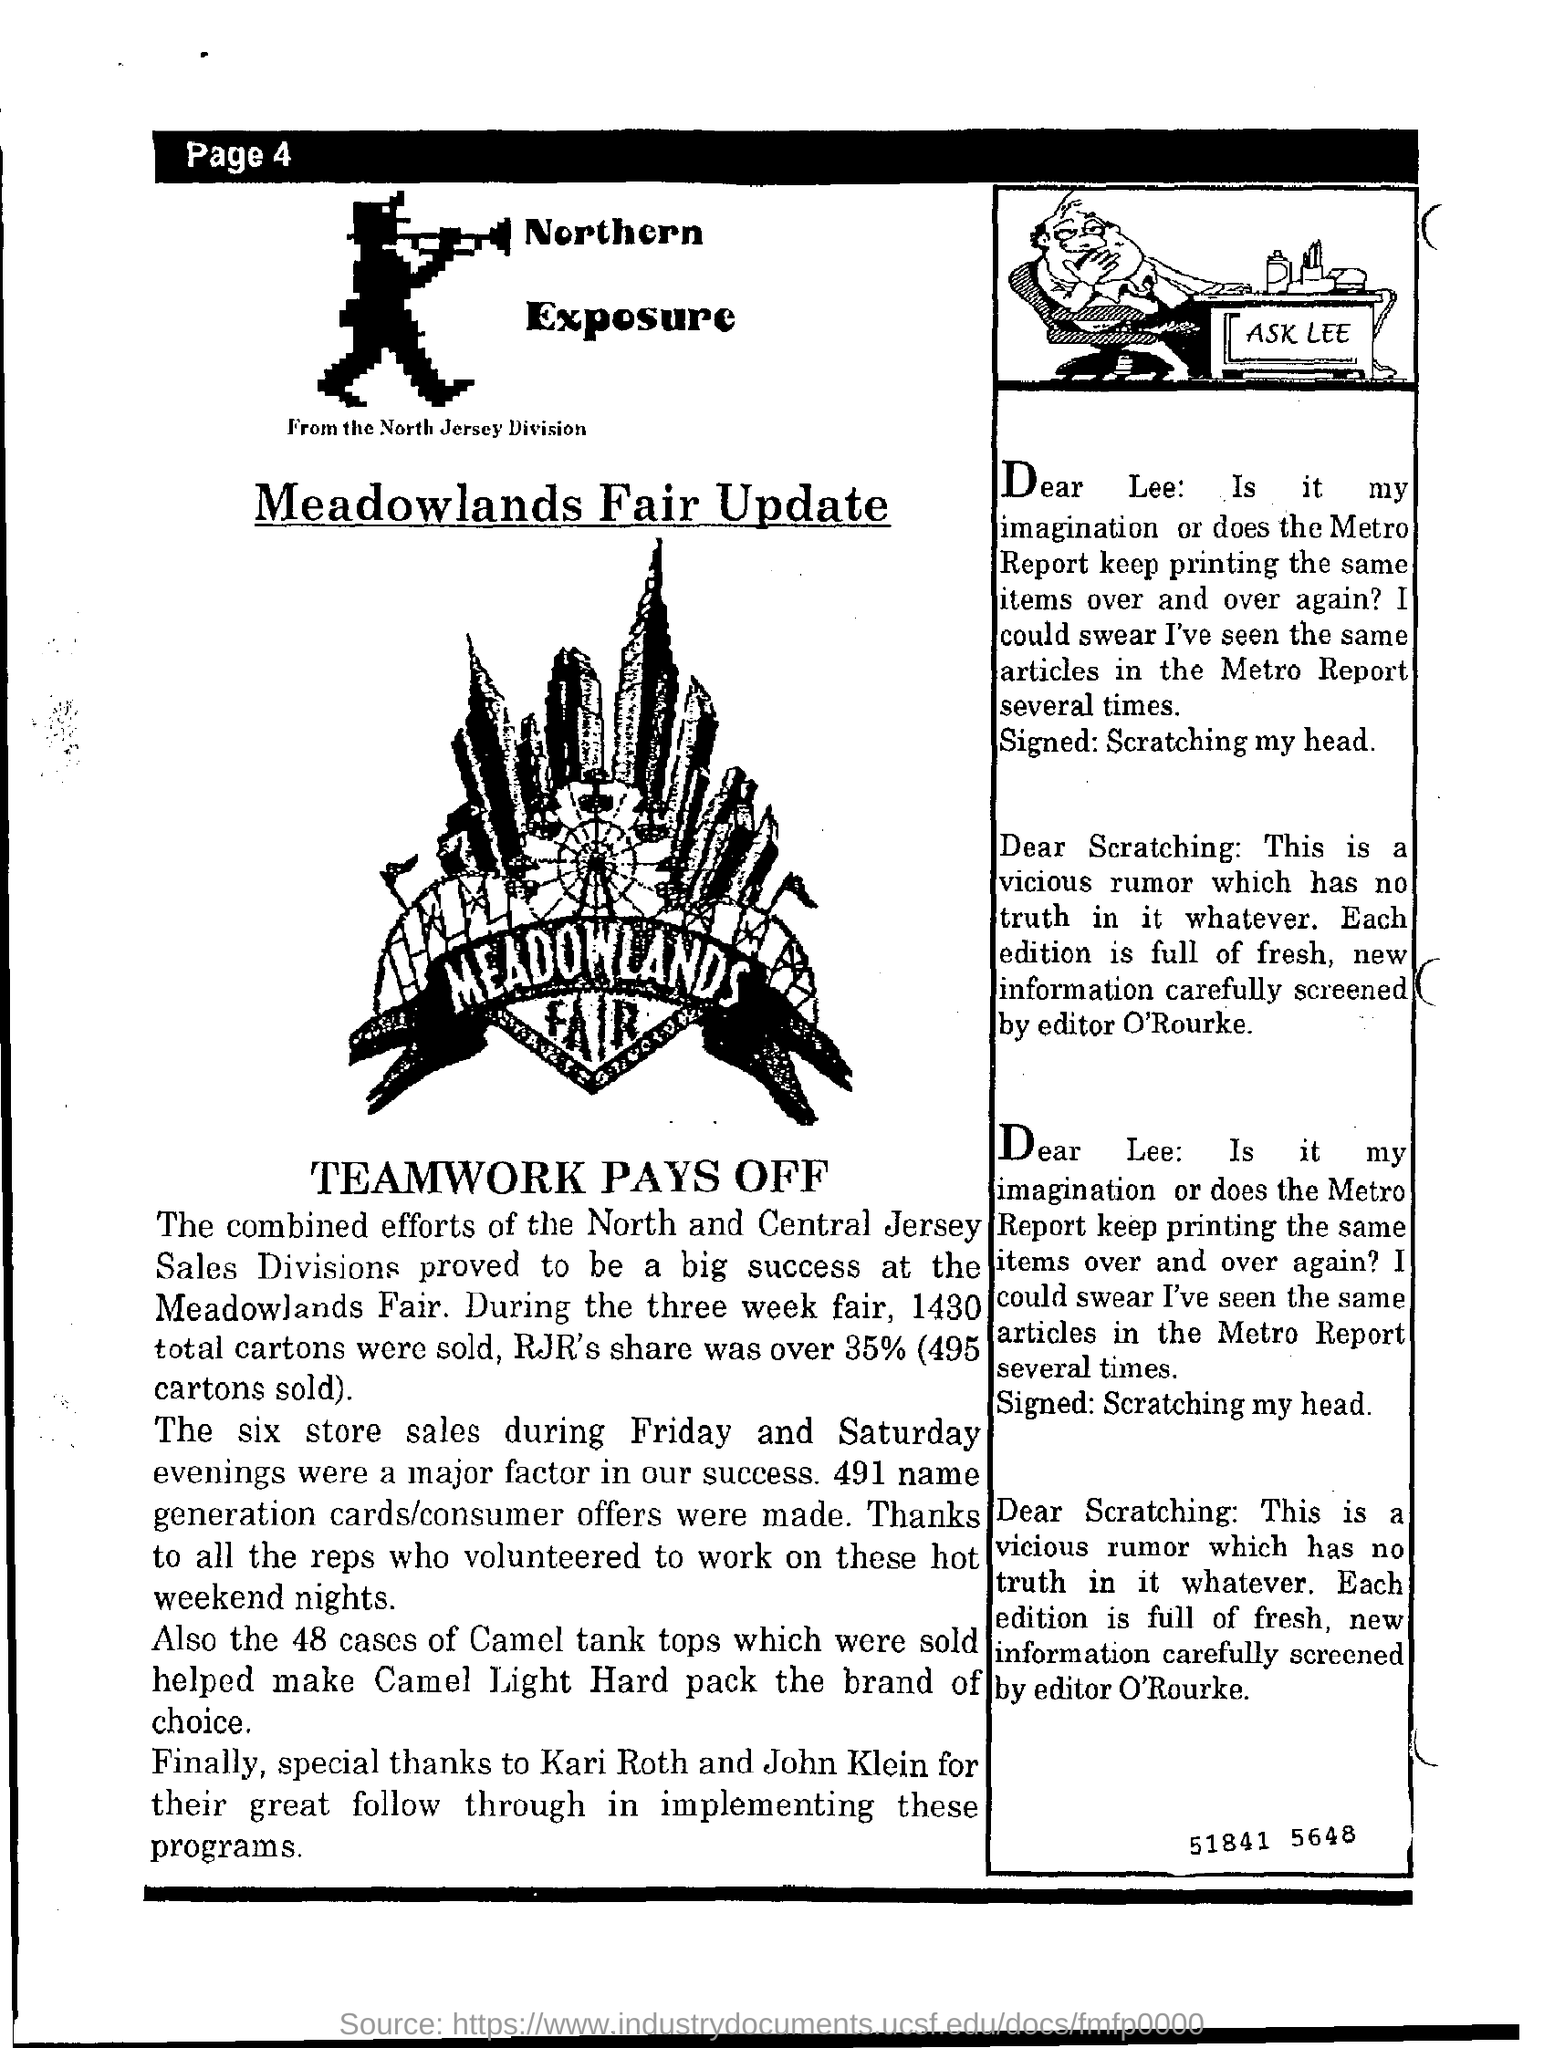Draw attention to some important aspects in this diagram. The editor is O'Rourke. RJR's share of sales during the three-week fair was over 35%, with a total of 495 cartons sold. It was Camel Light Hard Pack that was the brand of choice. 